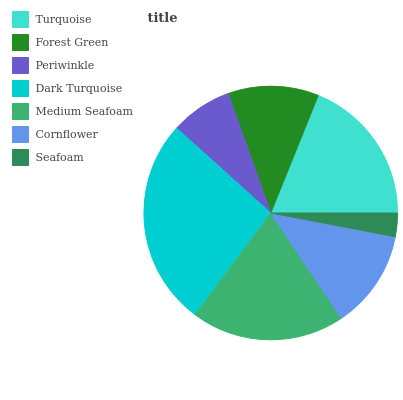Is Seafoam the minimum?
Answer yes or no. Yes. Is Dark Turquoise the maximum?
Answer yes or no. Yes. Is Forest Green the minimum?
Answer yes or no. No. Is Forest Green the maximum?
Answer yes or no. No. Is Turquoise greater than Forest Green?
Answer yes or no. Yes. Is Forest Green less than Turquoise?
Answer yes or no. Yes. Is Forest Green greater than Turquoise?
Answer yes or no. No. Is Turquoise less than Forest Green?
Answer yes or no. No. Is Cornflower the high median?
Answer yes or no. Yes. Is Cornflower the low median?
Answer yes or no. Yes. Is Turquoise the high median?
Answer yes or no. No. Is Seafoam the low median?
Answer yes or no. No. 